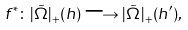<formula> <loc_0><loc_0><loc_500><loc_500>f ^ { * } \colon | \tilde { \Omega } | _ { + } ( h ) \longrightarrow | \tilde { \Omega } | _ { + } ( h ^ { \prime } ) ,</formula> 